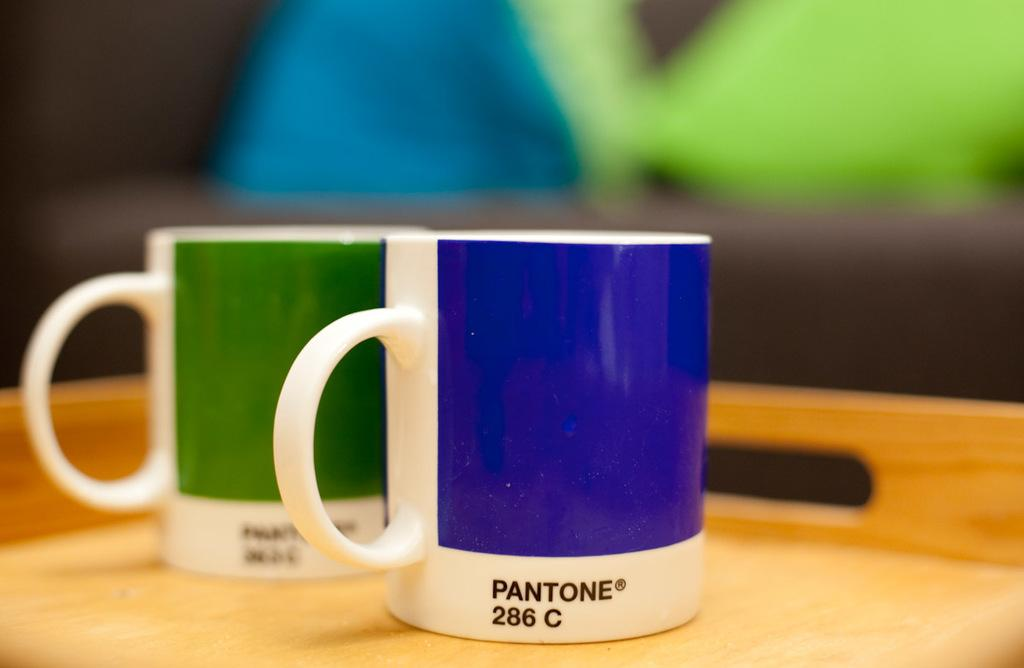<image>
Describe the image concisely. A blue mug with Pantone 286C sits next to a green mug that also has a Pantone label. 